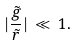<formula> <loc_0><loc_0><loc_500><loc_500>| \frac { \tilde { g } } { \tilde { r } } | \, \ll \, 1 .</formula> 